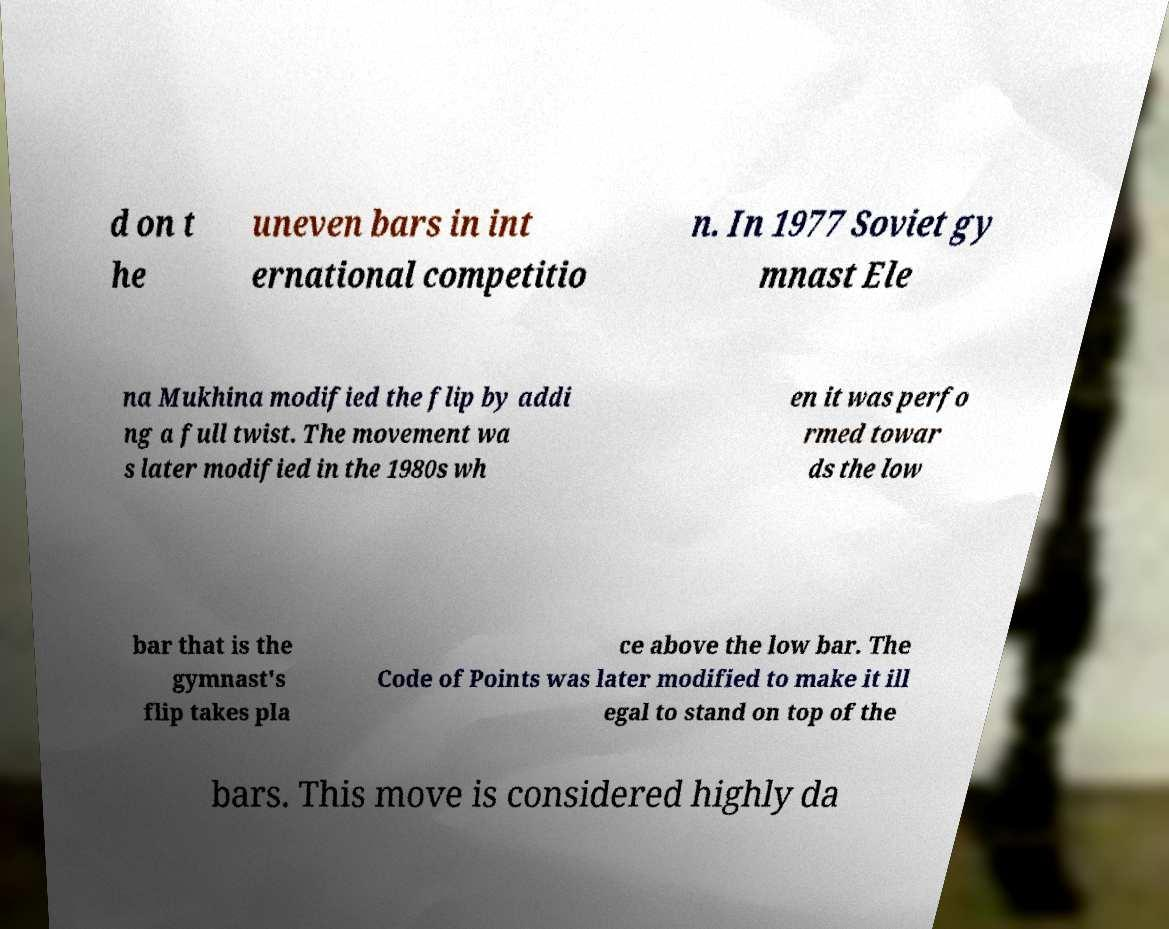There's text embedded in this image that I need extracted. Can you transcribe it verbatim? d on t he uneven bars in int ernational competitio n. In 1977 Soviet gy mnast Ele na Mukhina modified the flip by addi ng a full twist. The movement wa s later modified in the 1980s wh en it was perfo rmed towar ds the low bar that is the gymnast's flip takes pla ce above the low bar. The Code of Points was later modified to make it ill egal to stand on top of the bars. This move is considered highly da 